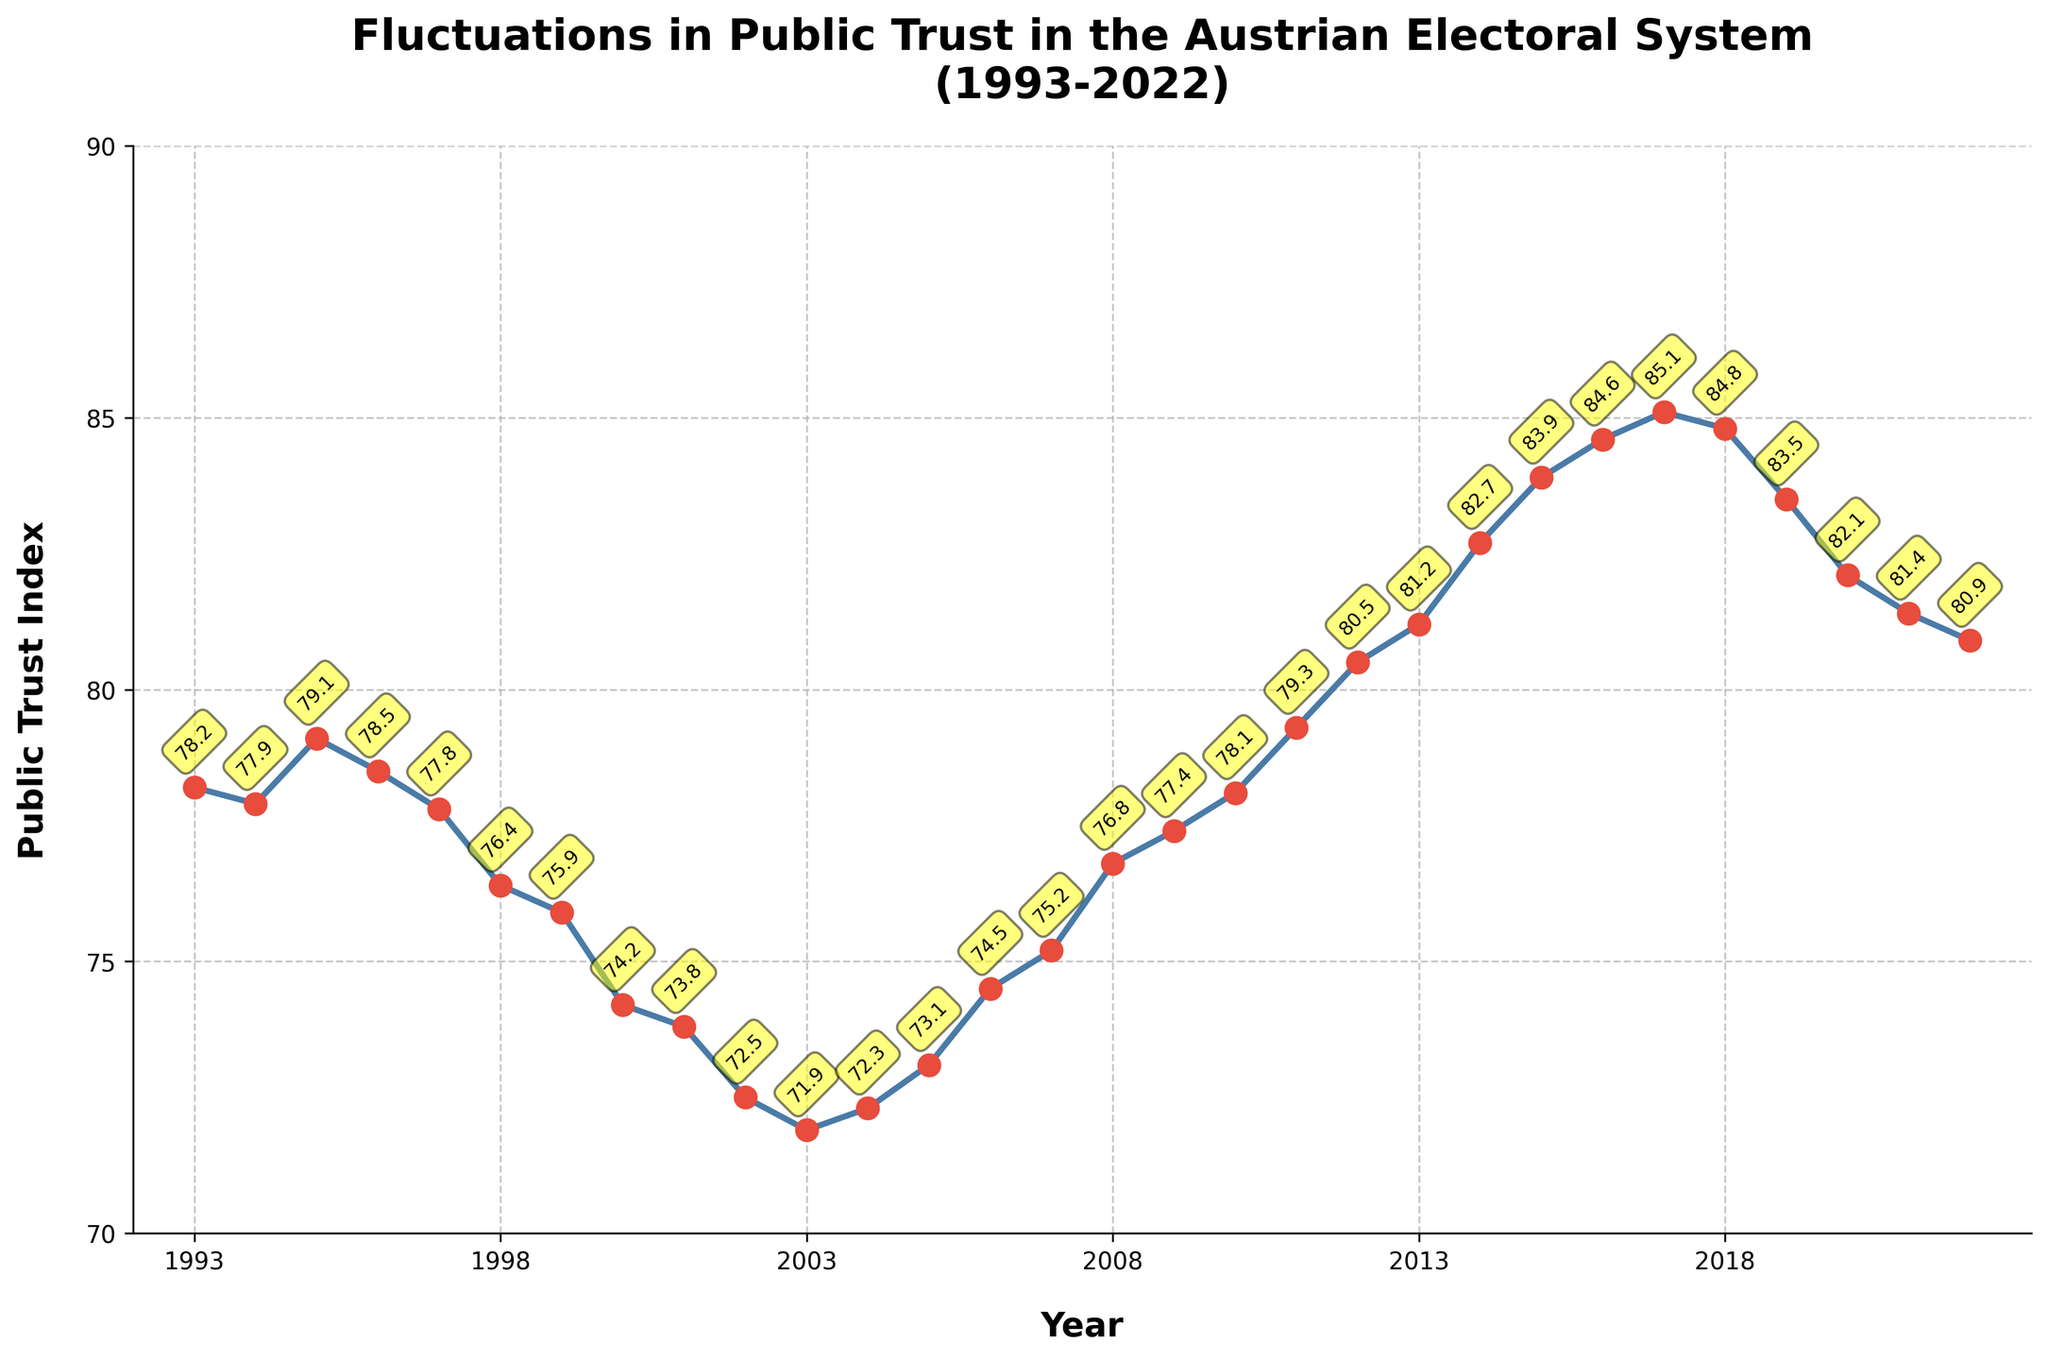What is the highest value of the Public Trust Index in the given period? The highest value can be found by visually scanning through the line chart and identifying the peak value. The highest value is shown with a marker and a corresponding annotation.
Answer: 85.1 In which year did the Public Trust Index reach its lowest point? The lowest point of the Public Trust Index is identified by finding the minimum value on the y-axis labeled and annotated. This can be found around the year 2003.
Answer: 71.9 How did the Public Trust Index change between 2000 and 2002? To understand the change, observe the Index values for the years 2000 and 2002 and calculate the difference between them. The values for 2000 and 2002 are 74.2 and 72.5, respectively, showing a decrease.
Answer: Decrease by 1.7 What is the average Public Trust Index between 2012 and 2016? Calculate the average by adding the values from 2012 to 2016 and dividing by the number of years. The values are 80.5, 81.2, 82.7, 83.9, and 84.6. So, (80.5 + 81.2 + 82.7 + 83.9 + 84.6)/5 = 82.58.
Answer: 82.58 Did the Public Trust Index generally increase or decrease over the three decades? Observing the overall trend from the start (1993) to the end (2022), we see the line chart going up, indicating an overall increase.
Answer: Increase Was the Public Trust Index higher in 2010 or 2020? Compare the values of the Public Trust Index for 2010 and 2020 from the chart. The values are 78.1 and 82.1 respectively, so it was higher in 2020.
Answer: 2020 Between which consecutive years did the Public Trust Index drop the most significantly? Identify the year-to-year changes and find the largest drop. The most significant drop appears between 2018 (84.8) and 2019 (83.5) which is a drop of 1.3.
Answer: 2018 to 2019 What was the Public Trust Index value in the middle of the time period, around the year 2007? Locate the value for the year 2007 visually on the line chart. The value for 2007 is 75.2.
Answer: 75.2 How many times did the Public Trust Index cross the value of 80.0? Count the number of times the line crosses the 80 mark visually in the chart. It crosses in 2012 and 2013.
Answer: Twice What was the difference in the Public Trust Index between the years 2005 and 2015? Calculate the difference by subtracting the value in 2005 (73.1) from the value in 2015 (83.9). The difference is 83.9 - 73.1 = 10.8.
Answer: 10.8 